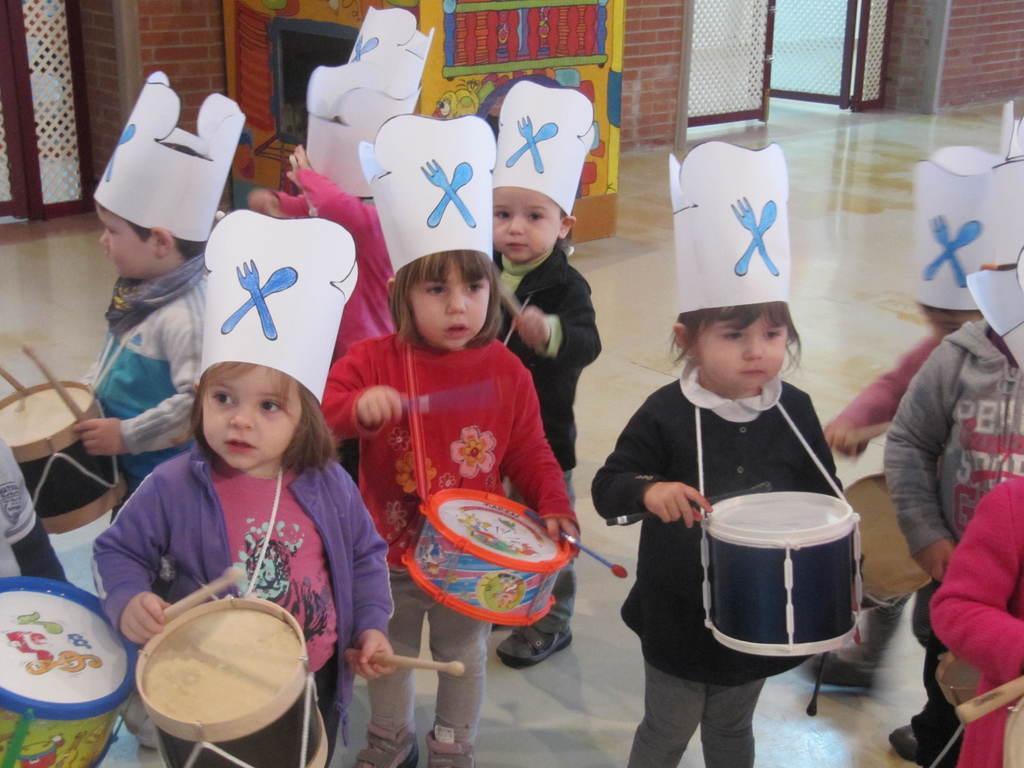Could you give a brief overview of what you see in this image? In this image I can see the group of children holding the drums. 